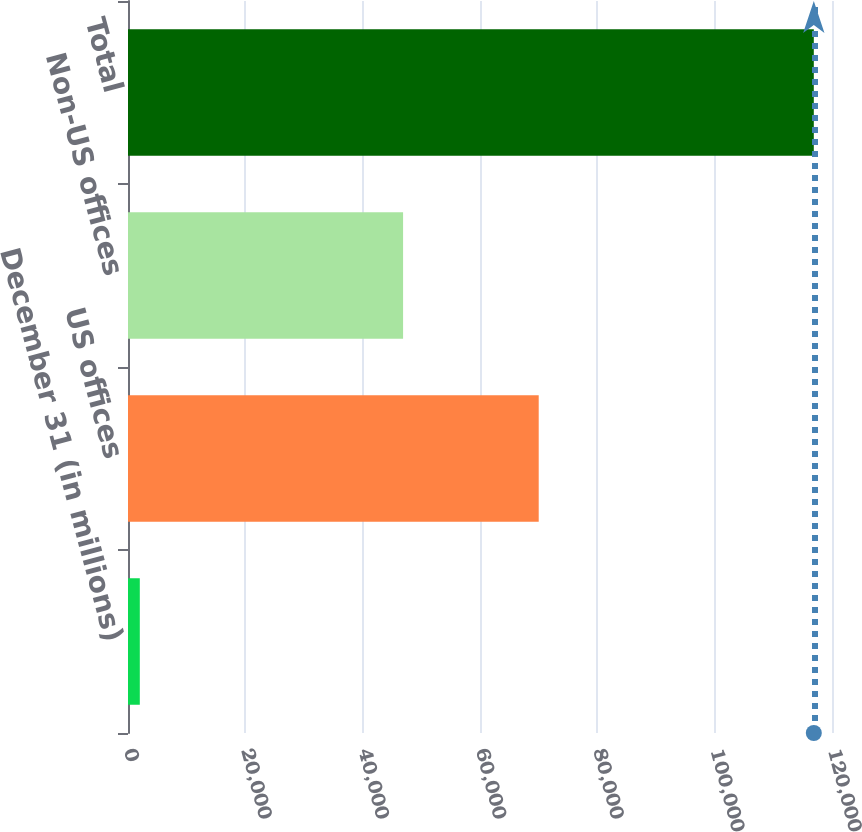Convert chart to OTSL. <chart><loc_0><loc_0><loc_500><loc_500><bar_chart><fcel>December 31 (in millions)<fcel>US offices<fcel>Non-US offices<fcel>Total<nl><fcel>2012<fcel>70008<fcel>46890<fcel>116898<nl></chart> 